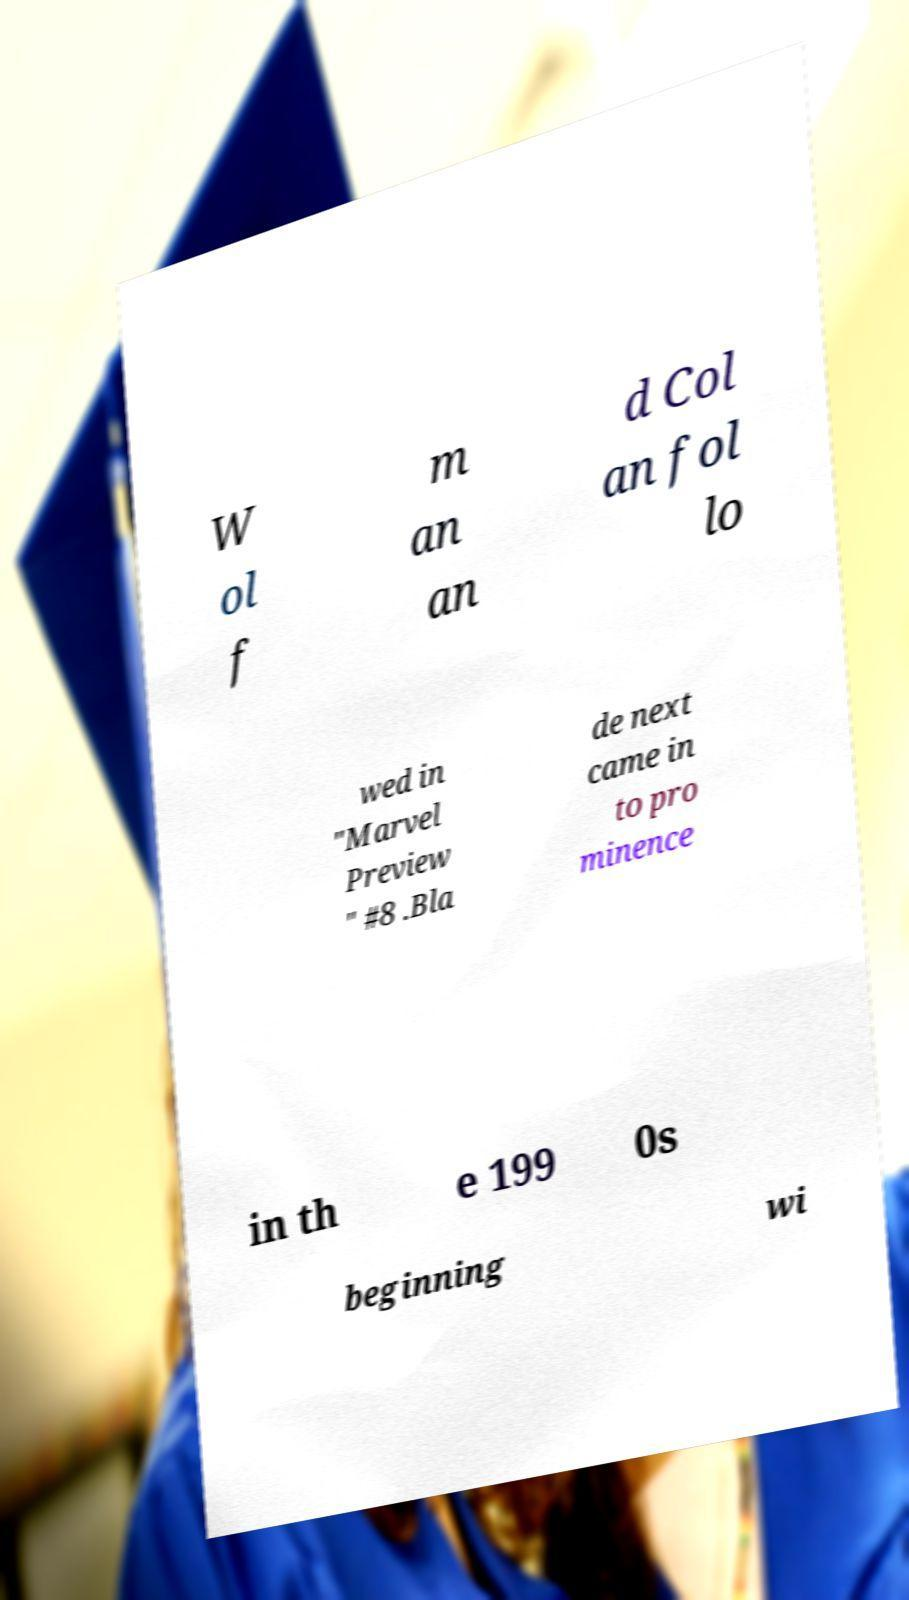Could you extract and type out the text from this image? W ol f m an an d Col an fol lo wed in "Marvel Preview " #8 .Bla de next came in to pro minence in th e 199 0s beginning wi 